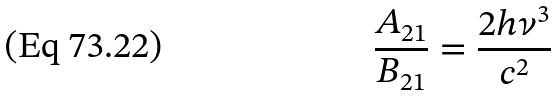<formula> <loc_0><loc_0><loc_500><loc_500>\frac { A _ { 2 1 } } { B _ { 2 1 } } = \frac { 2 h \nu ^ { 3 } } { c ^ { 2 } }</formula> 